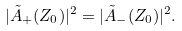<formula> <loc_0><loc_0><loc_500><loc_500>| { \tilde { A } } _ { + } ( Z _ { 0 } ) | ^ { 2 } = | { \tilde { A } } _ { - } ( Z _ { 0 } ) | ^ { 2 } .</formula> 